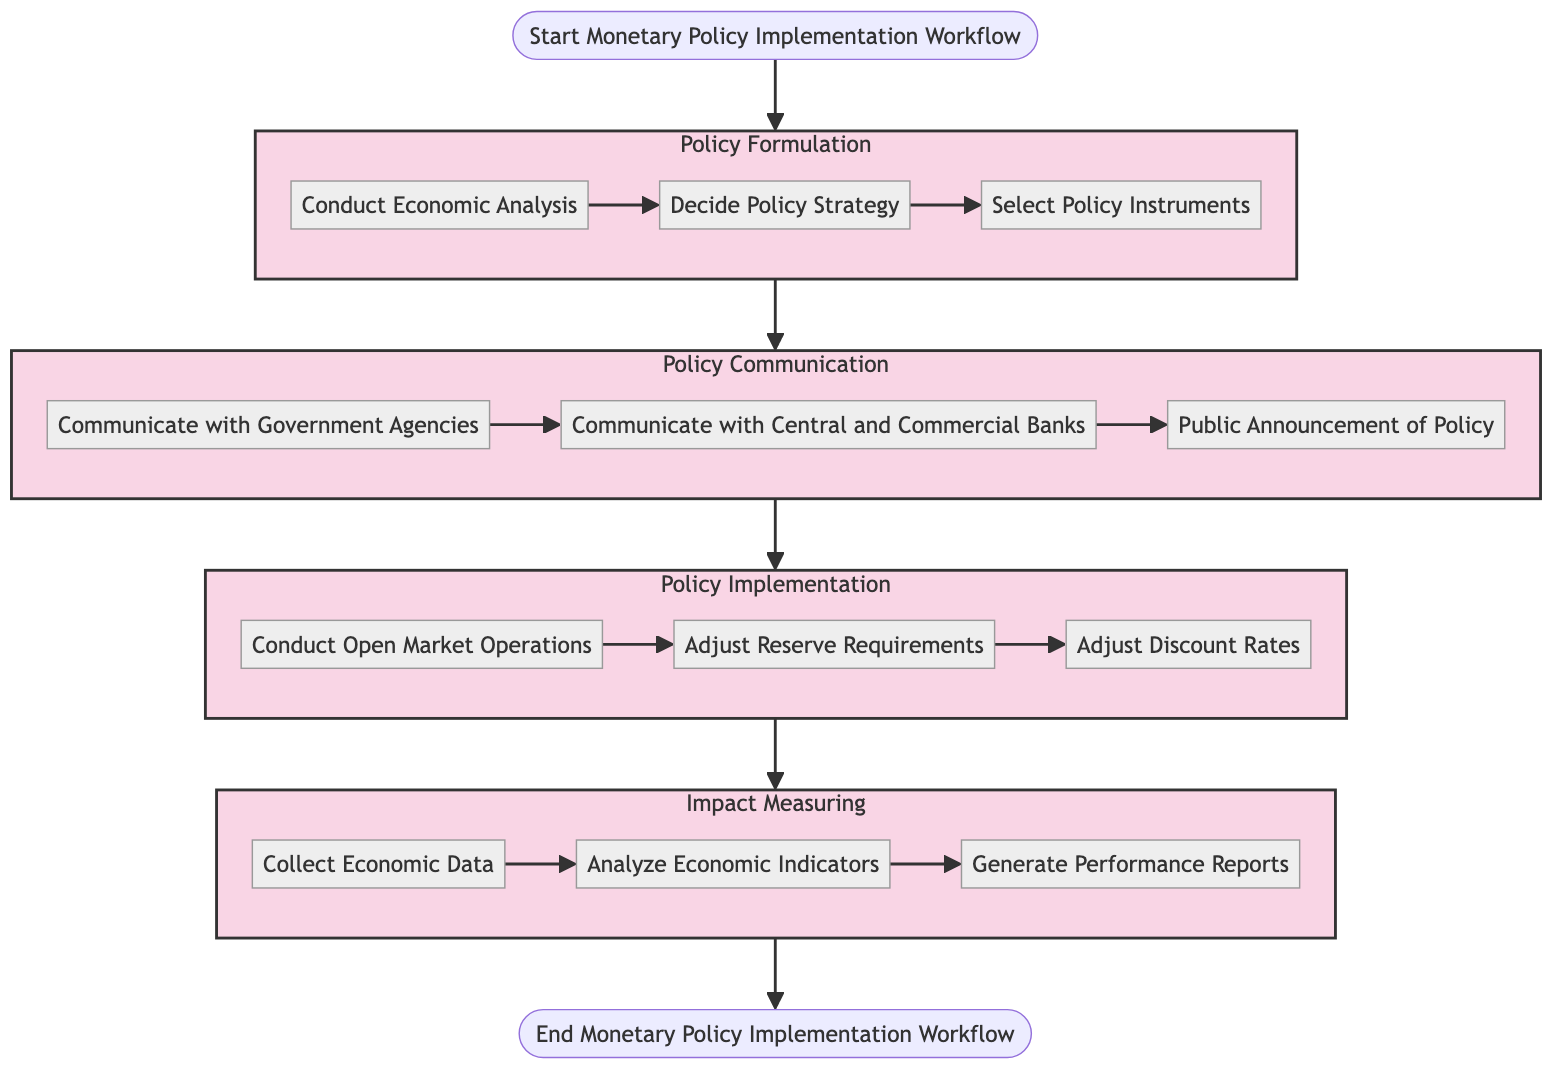What is the first step in the workflow? The diagram shows that the workflow starts with the "Start Monetary Policy Implementation Workflow" node, leading to the first stage of "Policy Formulation". The first step within "Policy Formulation" is "Conduct Economic Analysis".
Answer: Conduct Economic Analysis How many main stages are in the workflow? Analyzing the diagram, there are four main stages identified: "Policy Formulation", "Policy Communication", "Policy Implementation", and "Impact Measuring". Counting these stages confirms there are four.
Answer: Four What step immediately follows "Decide Policy Strategy"? Following the flow in the diagram from "Decide Policy Strategy", the next step is "Select Policy Instruments". This is derived from the sequential relationship indicated by the arrows.
Answer: Select Policy Instruments Which step involves banks? The diagram indicates the step "Communicate with Central and Commercial Banks" within the "Policy Communication" stage as the one that directly involves banks. This is clearly marked in the flowchart.
Answer: Communicate with Central and Commercial Banks What is the last step in the impact measuring stage? Within the "Impact Measuring" stage, the final step is "Generate Performance Reports". This can be confirmed by following the flow from "Collect Economic Data" to "Analyze Economic Indicators" and finally to this last step.
Answer: Generate Performance Reports How does the policy implementation stage connect to the impact measuring stage? The diagram shows a direct connection from the last step of "Policy Implementation" (after "Adjust Discount Rates") to the first step of "Impact Measuring" (to "Collect Economic Data"). This indicates a sequential transition from implementation to measuring the impact.
Answer: Direct connection What is the total number of steps in the workflow? To calculate the total number of steps, we count the individual steps across all stages: 3 in "Policy Formulation", 3 in "Policy Communication", 3 in "Policy Implementation", and 3 in "Impact Measuring", resulting in a total of 12 steps.
Answer: Twelve What is the relationship between "Gather Economic Data" and "Analyze Economic Indicators"? The relationship is sequential, indicated by the diagram's arrows. "Collect Economic Data" precedes "Analyze Economic Indicators", establishing a direct flow of information between these two steps in the workflow.
Answer: Sequential relationship 